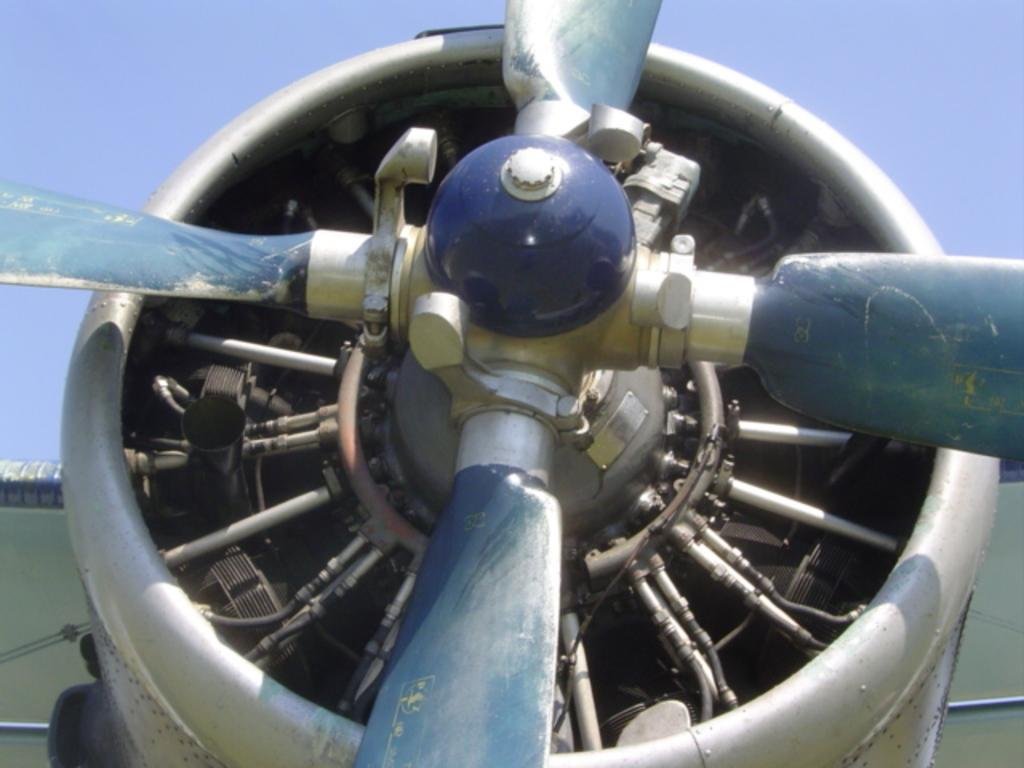What is the main object in the image? There is an object in the image, but the specific details are not provided. What feature does the main object have? The main object has wings. Are there any other objects related to the main object? Yes, there are other objects associated with the main object. Can you hear the object laughing in the image? There is no indication of sound or laughter in the image, as it is a visual representation. 